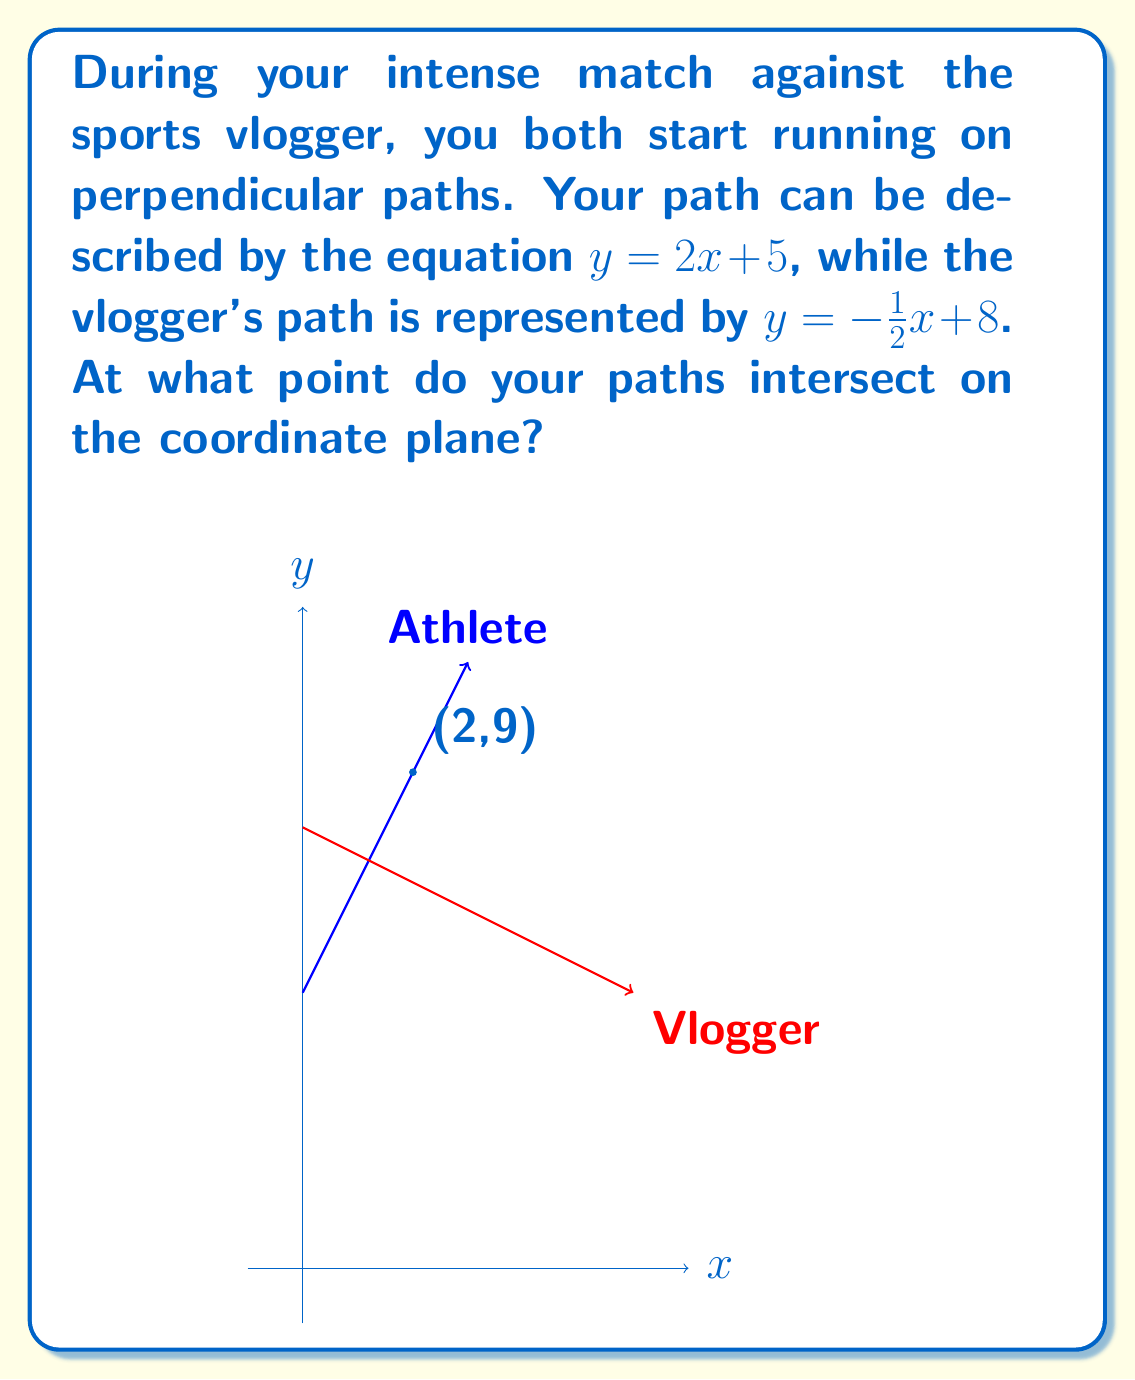Show me your answer to this math problem. To find the intersection point of the two paths, we need to solve the system of equations:

$$\begin{cases}
y = 2x + 5 \\
y = -\frac{1}{2}x + 8
\end{cases}$$

We can solve this system by equating the two equations:

$$2x + 5 = -\frac{1}{2}x + 8$$

Now, let's solve for $x$:

1) Add $\frac{1}{2}x$ to both sides:
   $$2x + \frac{1}{2}x + 5 = 8$$
   $$\frac{5}{2}x + 5 = 8$$

2) Subtract 5 from both sides:
   $$\frac{5}{2}x = 3$$

3) Multiply both sides by $\frac{2}{5}$:
   $$x = \frac{2}{5} \cdot 3 = \frac{6}{5} = 2$$

Now that we know $x = 2$, we can substitute this into either of the original equations to find $y$. Let's use your equation:

$$y = 2x + 5$$
$$y = 2(2) + 5 = 4 + 5 = 9$$

Therefore, the intersection point is $(2, 9)$.
Answer: $(2, 9)$ 